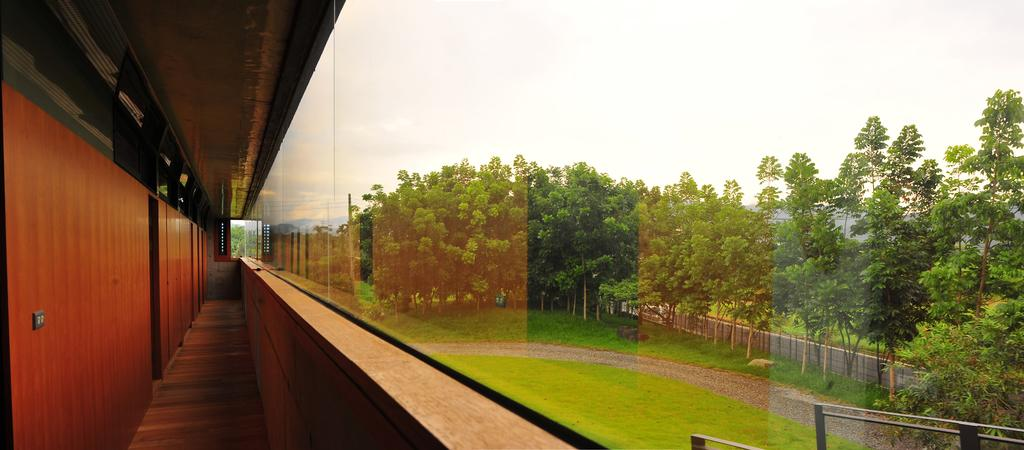What type of structure is visible in the image? There is a building in the image. What can be seen on the right side of the image? There is a group of trees and a barricade on the right side of the image. What is visible in the background of the image? The sky is visible in the background of the image. What type of game is being played in the image? There is no game being played in the image; it features a building, trees, a barricade, and the sky. Can you see any matches in the image? There are no matches present in the image. 